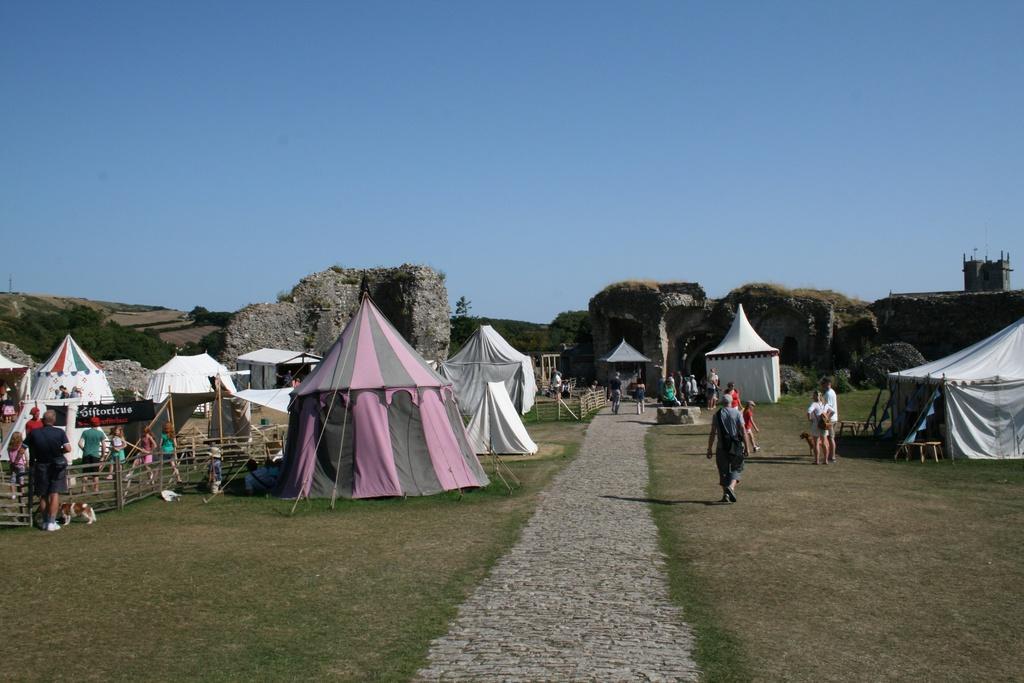Please provide a concise description of this image. In this image there are group of people ,tents, wooden fence,name board , and in the background there are trees,sky. 